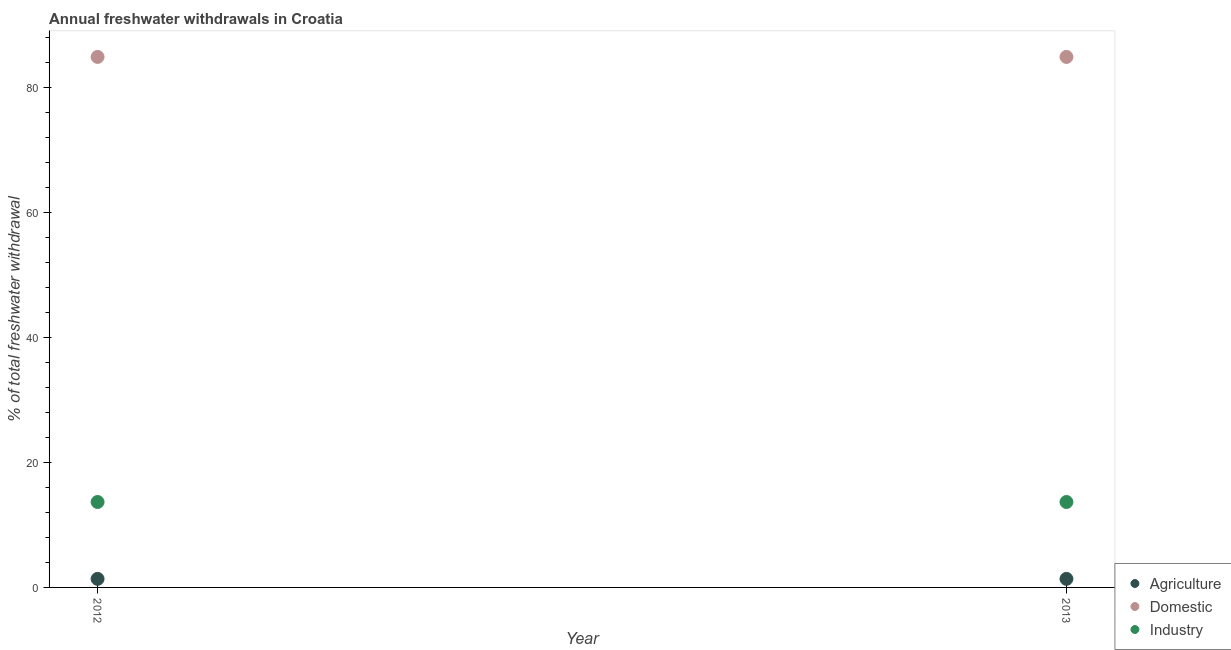What is the percentage of freshwater withdrawal for industry in 2012?
Offer a very short reply. 13.68. Across all years, what is the maximum percentage of freshwater withdrawal for domestic purposes?
Offer a very short reply. 84.95. Across all years, what is the minimum percentage of freshwater withdrawal for industry?
Offer a very short reply. 13.68. What is the total percentage of freshwater withdrawal for domestic purposes in the graph?
Make the answer very short. 169.9. What is the difference between the percentage of freshwater withdrawal for agriculture in 2012 and that in 2013?
Your response must be concise. 0. What is the difference between the percentage of freshwater withdrawal for industry in 2013 and the percentage of freshwater withdrawal for domestic purposes in 2012?
Make the answer very short. -71.27. What is the average percentage of freshwater withdrawal for domestic purposes per year?
Your answer should be compact. 84.95. In the year 2012, what is the difference between the percentage of freshwater withdrawal for agriculture and percentage of freshwater withdrawal for industry?
Make the answer very short. -12.31. In how many years, is the percentage of freshwater withdrawal for agriculture greater than 12 %?
Ensure brevity in your answer.  0. What is the ratio of the percentage of freshwater withdrawal for industry in 2012 to that in 2013?
Ensure brevity in your answer.  1. Is the percentage of freshwater withdrawal for agriculture in 2012 less than that in 2013?
Your answer should be very brief. No. In how many years, is the percentage of freshwater withdrawal for domestic purposes greater than the average percentage of freshwater withdrawal for domestic purposes taken over all years?
Make the answer very short. 0. Is it the case that in every year, the sum of the percentage of freshwater withdrawal for agriculture and percentage of freshwater withdrawal for domestic purposes is greater than the percentage of freshwater withdrawal for industry?
Offer a very short reply. Yes. Is the percentage of freshwater withdrawal for agriculture strictly less than the percentage of freshwater withdrawal for domestic purposes over the years?
Your answer should be compact. Yes. Are the values on the major ticks of Y-axis written in scientific E-notation?
Provide a succinct answer. No. Where does the legend appear in the graph?
Provide a short and direct response. Bottom right. How many legend labels are there?
Make the answer very short. 3. How are the legend labels stacked?
Your answer should be compact. Vertical. What is the title of the graph?
Offer a terse response. Annual freshwater withdrawals in Croatia. What is the label or title of the Y-axis?
Your response must be concise. % of total freshwater withdrawal. What is the % of total freshwater withdrawal in Agriculture in 2012?
Provide a short and direct response. 1.37. What is the % of total freshwater withdrawal of Domestic in 2012?
Give a very brief answer. 84.95. What is the % of total freshwater withdrawal in Industry in 2012?
Your answer should be compact. 13.68. What is the % of total freshwater withdrawal in Agriculture in 2013?
Provide a succinct answer. 1.37. What is the % of total freshwater withdrawal in Domestic in 2013?
Your response must be concise. 84.95. What is the % of total freshwater withdrawal in Industry in 2013?
Your answer should be very brief. 13.68. Across all years, what is the maximum % of total freshwater withdrawal of Agriculture?
Ensure brevity in your answer.  1.37. Across all years, what is the maximum % of total freshwater withdrawal in Domestic?
Provide a succinct answer. 84.95. Across all years, what is the maximum % of total freshwater withdrawal of Industry?
Offer a very short reply. 13.68. Across all years, what is the minimum % of total freshwater withdrawal of Agriculture?
Keep it short and to the point. 1.37. Across all years, what is the minimum % of total freshwater withdrawal of Domestic?
Provide a succinct answer. 84.95. Across all years, what is the minimum % of total freshwater withdrawal of Industry?
Ensure brevity in your answer.  13.68. What is the total % of total freshwater withdrawal of Agriculture in the graph?
Offer a very short reply. 2.74. What is the total % of total freshwater withdrawal in Domestic in the graph?
Give a very brief answer. 169.9. What is the total % of total freshwater withdrawal in Industry in the graph?
Offer a very short reply. 27.36. What is the difference between the % of total freshwater withdrawal of Domestic in 2012 and that in 2013?
Offer a terse response. 0. What is the difference between the % of total freshwater withdrawal of Industry in 2012 and that in 2013?
Provide a succinct answer. 0. What is the difference between the % of total freshwater withdrawal in Agriculture in 2012 and the % of total freshwater withdrawal in Domestic in 2013?
Your answer should be very brief. -83.58. What is the difference between the % of total freshwater withdrawal of Agriculture in 2012 and the % of total freshwater withdrawal of Industry in 2013?
Offer a terse response. -12.31. What is the difference between the % of total freshwater withdrawal in Domestic in 2012 and the % of total freshwater withdrawal in Industry in 2013?
Give a very brief answer. 71.27. What is the average % of total freshwater withdrawal in Agriculture per year?
Provide a succinct answer. 1.37. What is the average % of total freshwater withdrawal in Domestic per year?
Keep it short and to the point. 84.95. What is the average % of total freshwater withdrawal of Industry per year?
Give a very brief answer. 13.68. In the year 2012, what is the difference between the % of total freshwater withdrawal in Agriculture and % of total freshwater withdrawal in Domestic?
Make the answer very short. -83.58. In the year 2012, what is the difference between the % of total freshwater withdrawal in Agriculture and % of total freshwater withdrawal in Industry?
Your answer should be compact. -12.31. In the year 2012, what is the difference between the % of total freshwater withdrawal of Domestic and % of total freshwater withdrawal of Industry?
Provide a short and direct response. 71.27. In the year 2013, what is the difference between the % of total freshwater withdrawal in Agriculture and % of total freshwater withdrawal in Domestic?
Provide a succinct answer. -83.58. In the year 2013, what is the difference between the % of total freshwater withdrawal of Agriculture and % of total freshwater withdrawal of Industry?
Ensure brevity in your answer.  -12.31. In the year 2013, what is the difference between the % of total freshwater withdrawal in Domestic and % of total freshwater withdrawal in Industry?
Keep it short and to the point. 71.27. What is the ratio of the % of total freshwater withdrawal in Agriculture in 2012 to that in 2013?
Your answer should be very brief. 1. What is the difference between the highest and the second highest % of total freshwater withdrawal of Domestic?
Offer a terse response. 0. What is the difference between the highest and the lowest % of total freshwater withdrawal in Agriculture?
Give a very brief answer. 0. What is the difference between the highest and the lowest % of total freshwater withdrawal of Domestic?
Your answer should be very brief. 0. 